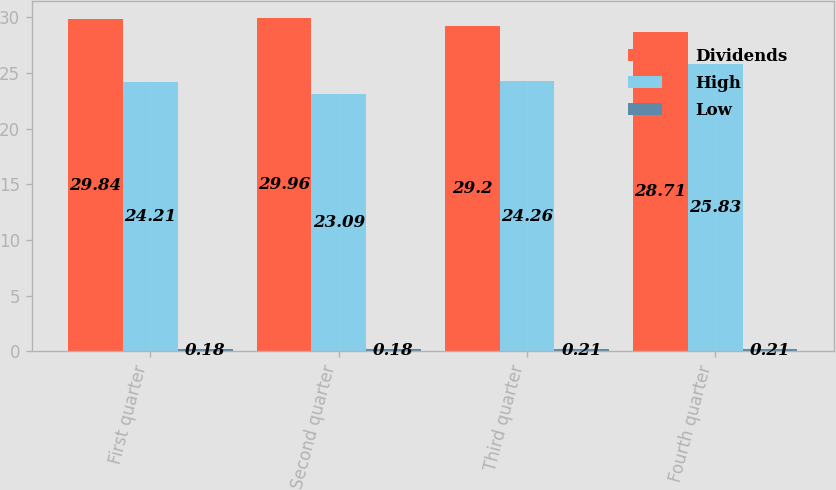<chart> <loc_0><loc_0><loc_500><loc_500><stacked_bar_chart><ecel><fcel>First quarter<fcel>Second quarter<fcel>Third quarter<fcel>Fourth quarter<nl><fcel>Dividends<fcel>29.84<fcel>29.96<fcel>29.2<fcel>28.71<nl><fcel>High<fcel>24.21<fcel>23.09<fcel>24.26<fcel>25.83<nl><fcel>Low<fcel>0.18<fcel>0.18<fcel>0.21<fcel>0.21<nl></chart> 